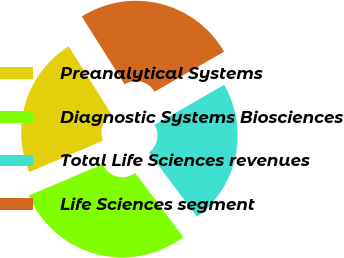<chart> <loc_0><loc_0><loc_500><loc_500><pie_chart><fcel>Preanalytical Systems<fcel>Diagnostic Systems Biosciences<fcel>Total Life Sciences revenues<fcel>Life Sciences segment<nl><fcel>22.44%<fcel>28.85%<fcel>23.08%<fcel>25.64%<nl></chart> 